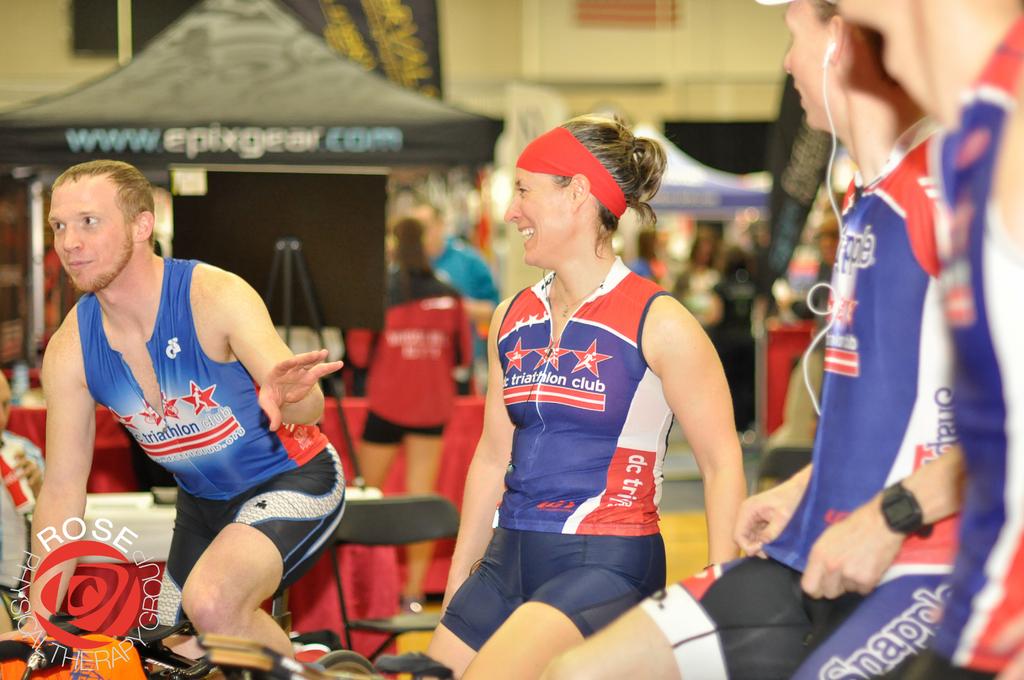What is the name of the group printed in the lower left corner?
Ensure brevity in your answer.  Rose physical therapy group. 